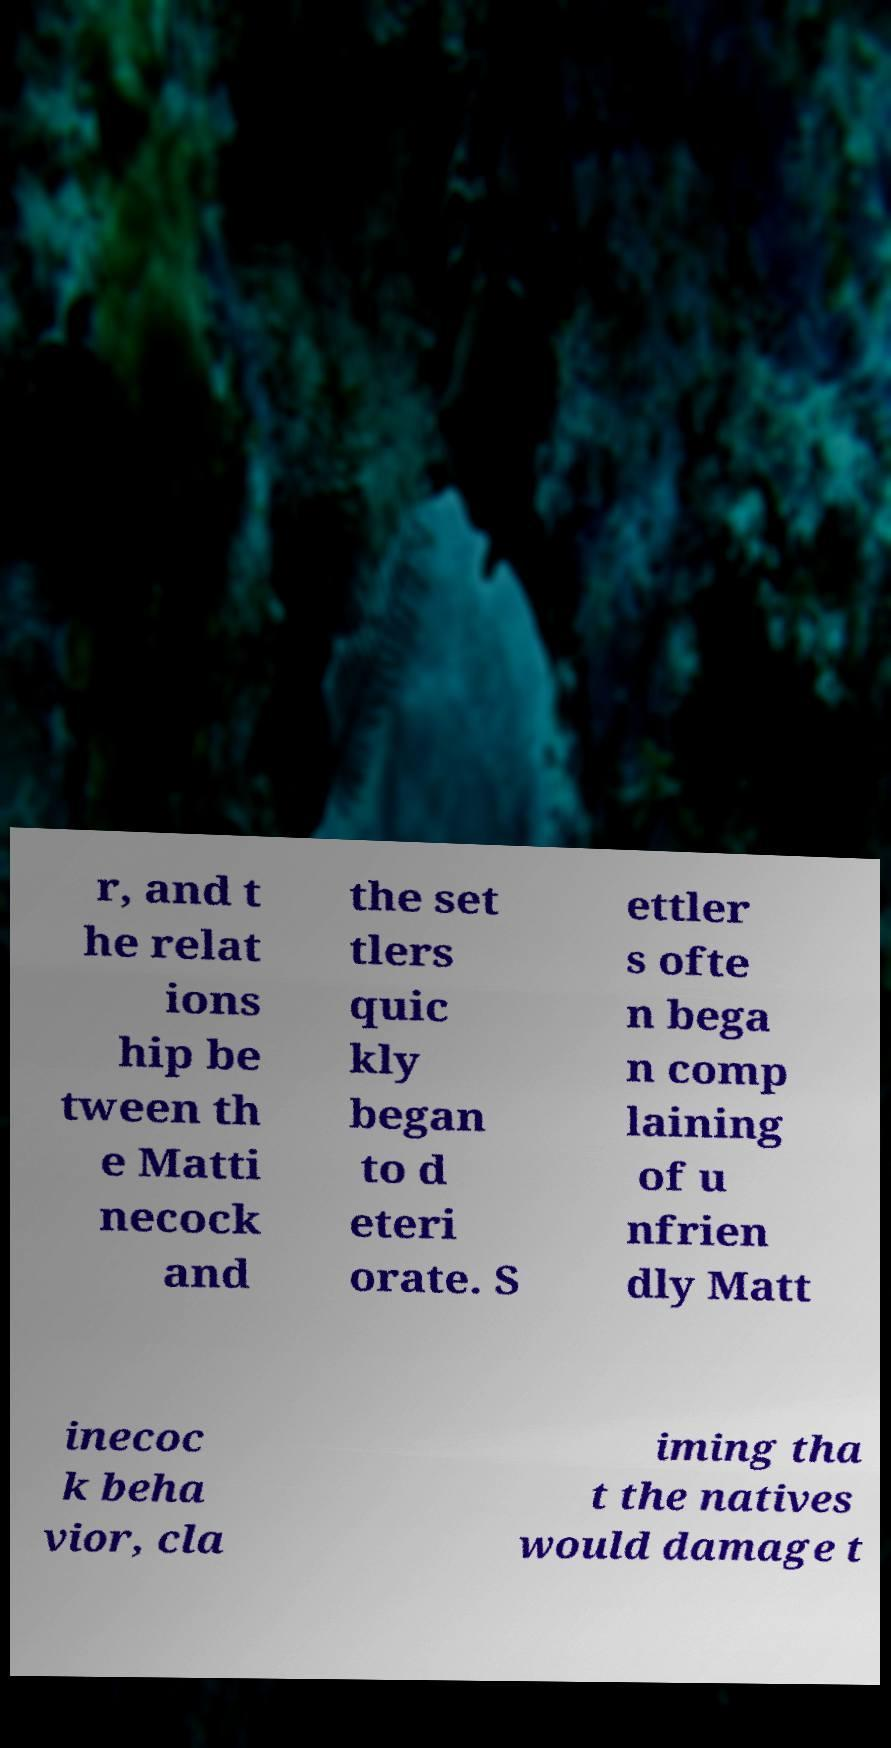Can you accurately transcribe the text from the provided image for me? r, and t he relat ions hip be tween th e Matti necock and the set tlers quic kly began to d eteri orate. S ettler s ofte n bega n comp laining of u nfrien dly Matt inecoc k beha vior, cla iming tha t the natives would damage t 